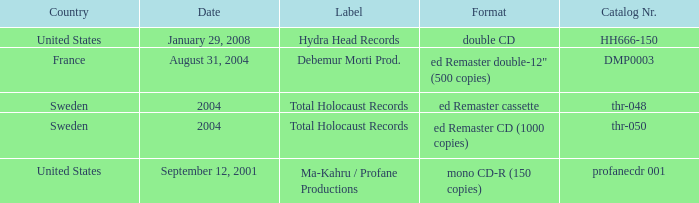Which country has the catalog nr of thr-048 in 2004? Sweden. 